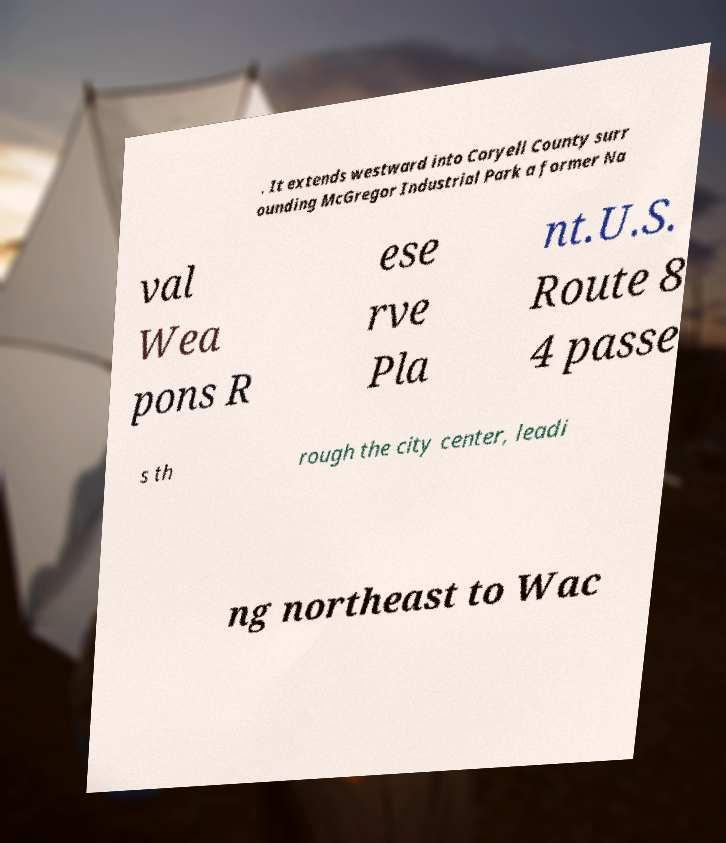For documentation purposes, I need the text within this image transcribed. Could you provide that? . It extends westward into Coryell County surr ounding McGregor Industrial Park a former Na val Wea pons R ese rve Pla nt.U.S. Route 8 4 passe s th rough the city center, leadi ng northeast to Wac 